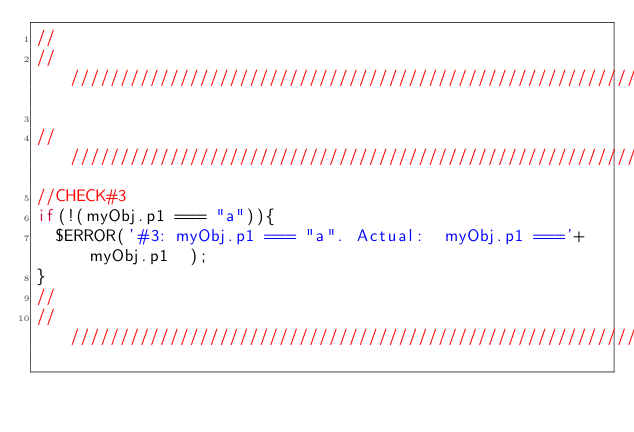<code> <loc_0><loc_0><loc_500><loc_500><_JavaScript_>//
//////////////////////////////////////////////////////////////////////////////

//////////////////////////////////////////////////////////////////////////////
//CHECK#3
if(!(myObj.p1 === "a")){
  $ERROR('#3: myObj.p1 === "a". Actual:  myObj.p1 ==='+ myObj.p1  );
}
//
//////////////////////////////////////////////////////////////////////////////





</code> 